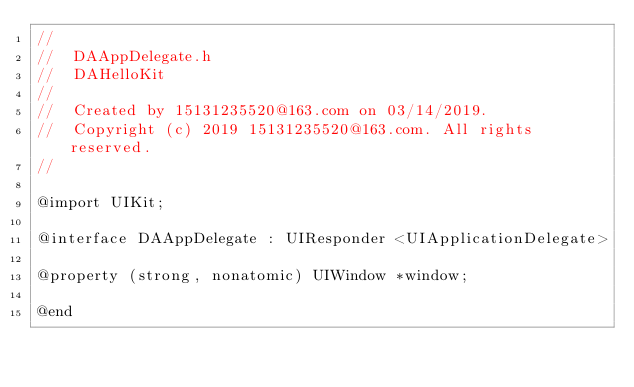<code> <loc_0><loc_0><loc_500><loc_500><_C_>//
//  DAAppDelegate.h
//  DAHelloKit
//
//  Created by 15131235520@163.com on 03/14/2019.
//  Copyright (c) 2019 15131235520@163.com. All rights reserved.
//

@import UIKit;

@interface DAAppDelegate : UIResponder <UIApplicationDelegate>

@property (strong, nonatomic) UIWindow *window;

@end
</code> 